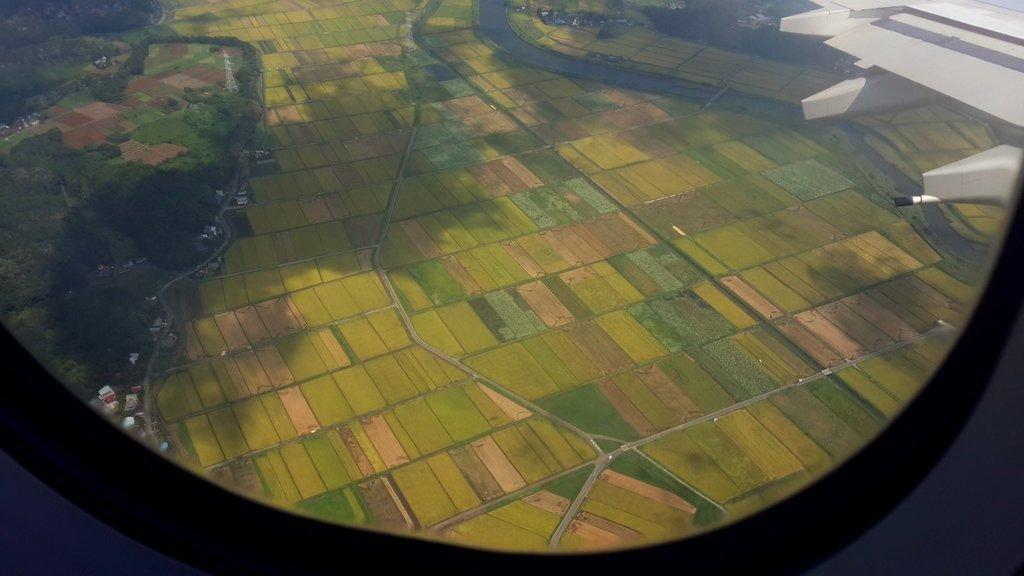In one or two sentences, can you explain what this image depicts? In this image we can see the inside of an aircraft. We can see a part of the aircraft at the right side of the image. There are many agricultural fields in the image. There is a road in the image. There are many houses in the image. There are many trees in the image. 